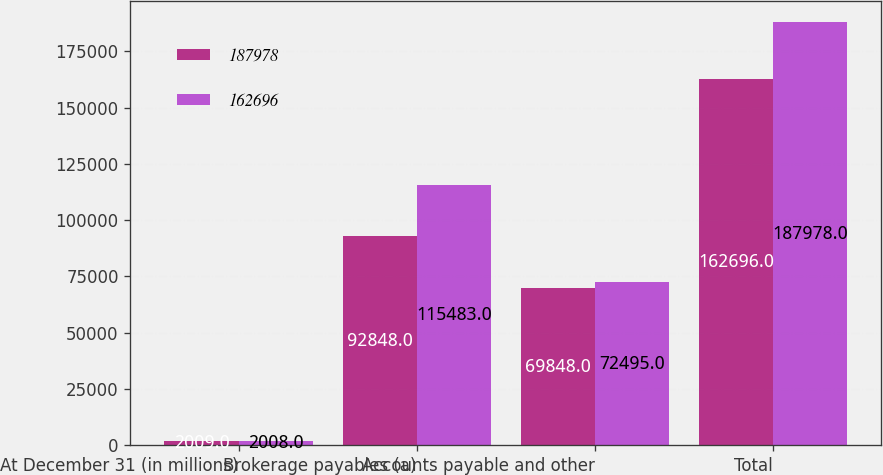Convert chart. <chart><loc_0><loc_0><loc_500><loc_500><stacked_bar_chart><ecel><fcel>At December 31 (in millions)<fcel>Brokerage payables (a)<fcel>Accounts payable and other<fcel>Total<nl><fcel>187978<fcel>2009<fcel>92848<fcel>69848<fcel>162696<nl><fcel>162696<fcel>2008<fcel>115483<fcel>72495<fcel>187978<nl></chart> 